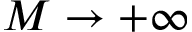<formula> <loc_0><loc_0><loc_500><loc_500>M \to + \infty</formula> 